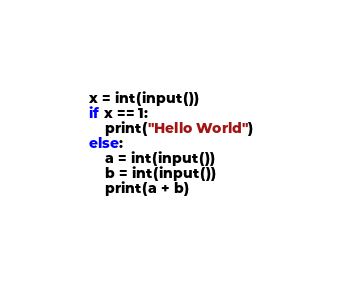Convert code to text. <code><loc_0><loc_0><loc_500><loc_500><_Python_>x = int(input())
if x == 1:
    print("Hello World")
else:
    a = int(input())
    b = int(input())
    print(a + b)</code> 